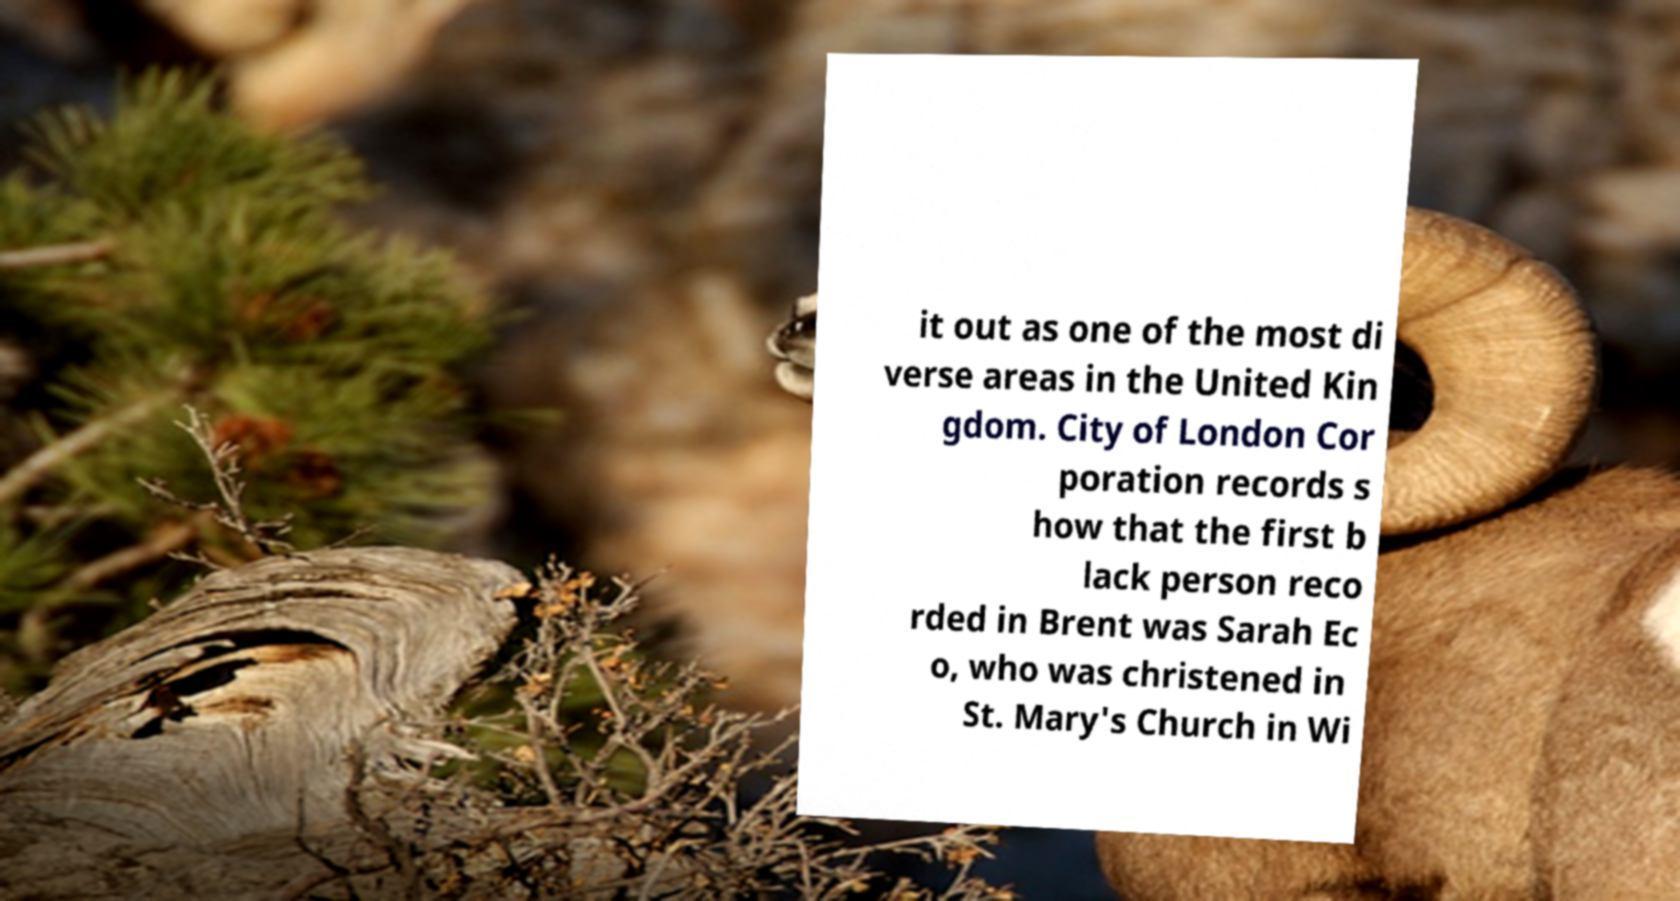Could you assist in decoding the text presented in this image and type it out clearly? it out as one of the most di verse areas in the United Kin gdom. City of London Cor poration records s how that the first b lack person reco rded in Brent was Sarah Ec o, who was christened in St. Mary's Church in Wi 